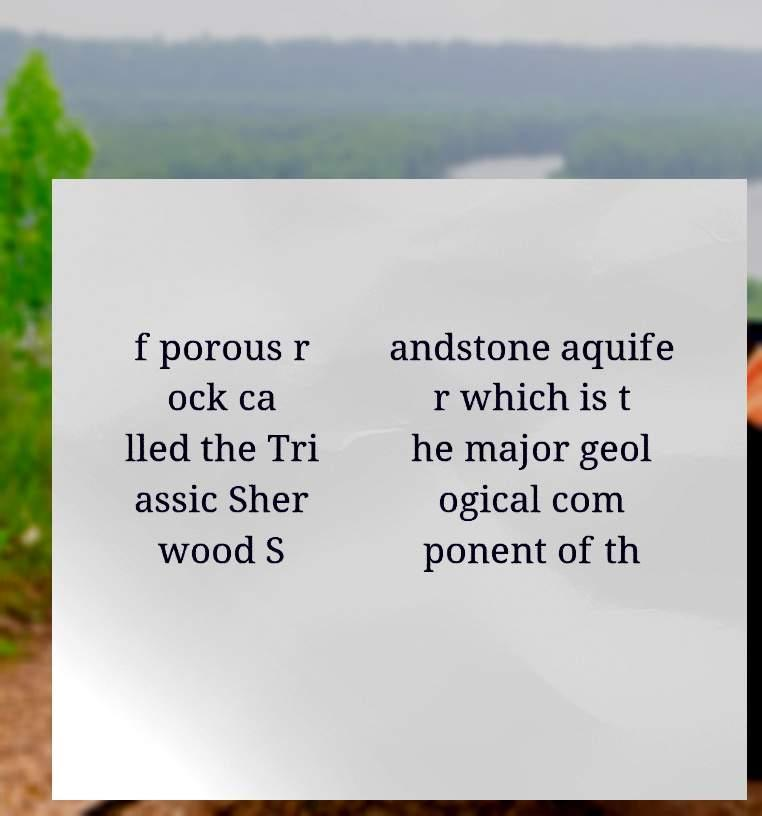Please read and relay the text visible in this image. What does it say? f porous r ock ca lled the Tri assic Sher wood S andstone aquife r which is t he major geol ogical com ponent of th 